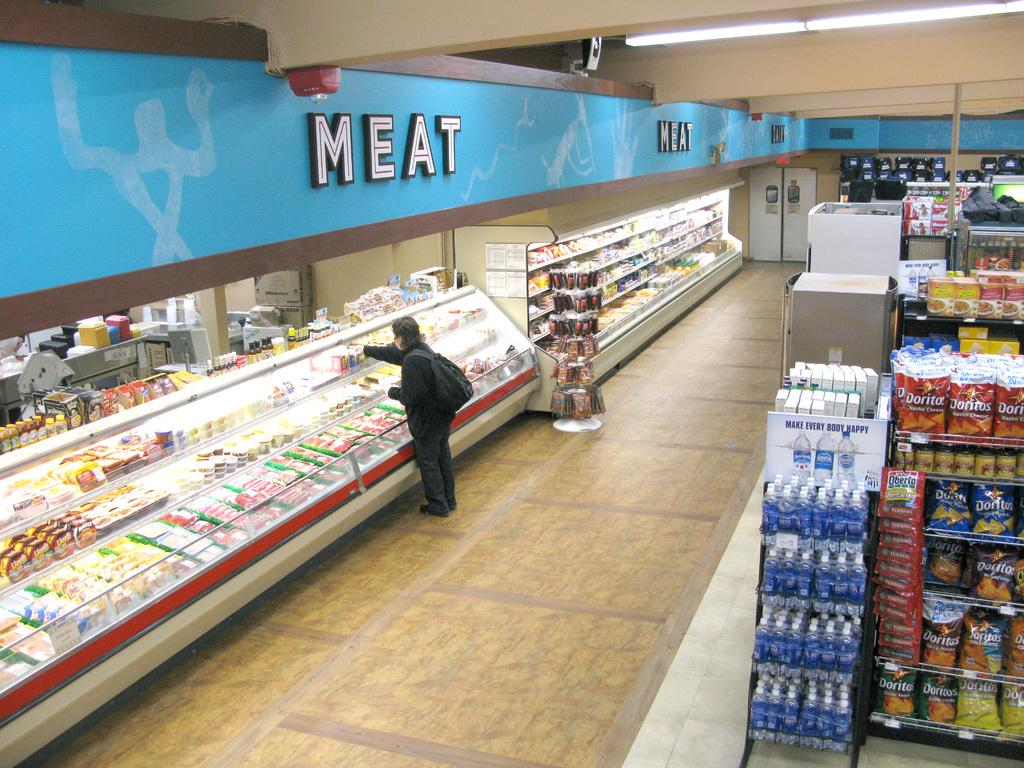Provide a one-sentence caption for the provided image. A person picking out meat in a grocery store. 